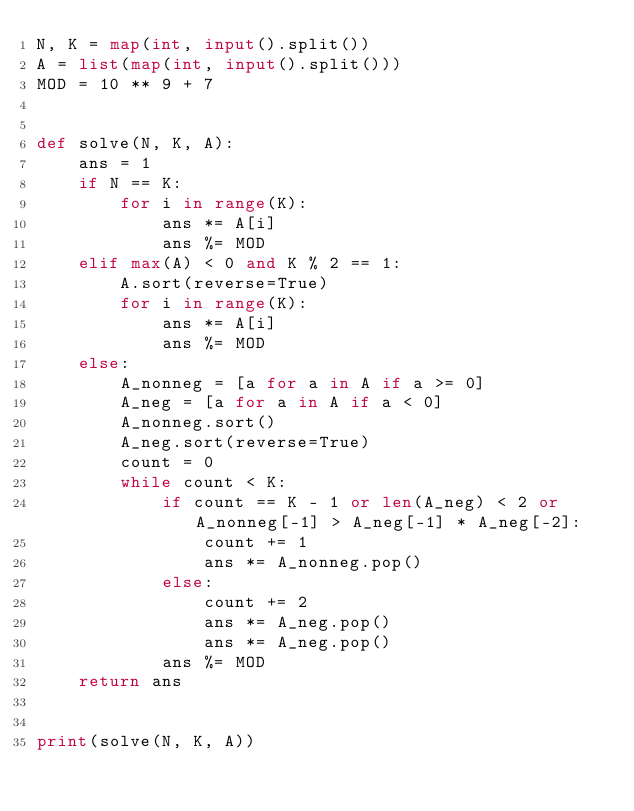Convert code to text. <code><loc_0><loc_0><loc_500><loc_500><_Python_>N, K = map(int, input().split())
A = list(map(int, input().split()))
MOD = 10 ** 9 + 7


def solve(N, K, A):
    ans = 1
    if N == K:
        for i in range(K):
            ans *= A[i]
            ans %= MOD
    elif max(A) < 0 and K % 2 == 1:
        A.sort(reverse=True)
        for i in range(K):
            ans *= A[i]
            ans %= MOD
    else:
        A_nonneg = [a for a in A if a >= 0]
        A_neg = [a for a in A if a < 0]
        A_nonneg.sort()
        A_neg.sort(reverse=True)
        count = 0
        while count < K:
            if count == K - 1 or len(A_neg) < 2 or A_nonneg[-1] > A_neg[-1] * A_neg[-2]:
                count += 1
                ans *= A_nonneg.pop()
            else:
                count += 2
                ans *= A_neg.pop()
                ans *= A_neg.pop()
            ans %= MOD
    return ans


print(solve(N, K, A))</code> 